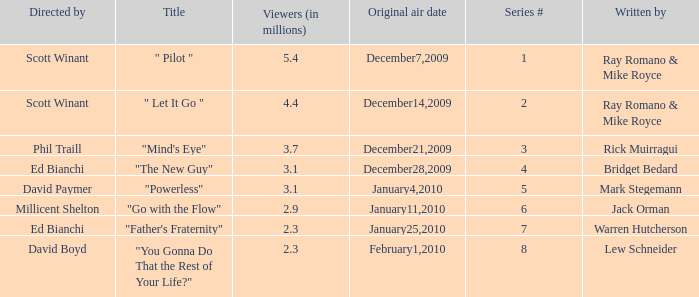What is the original air date of "Powerless"? January4,2010. 